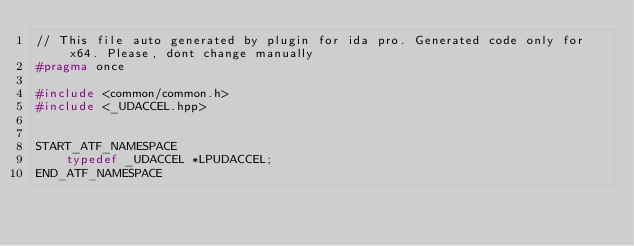<code> <loc_0><loc_0><loc_500><loc_500><_C++_>// This file auto generated by plugin for ida pro. Generated code only for x64. Please, dont change manually
#pragma once

#include <common/common.h>
#include <_UDACCEL.hpp>


START_ATF_NAMESPACE
    typedef _UDACCEL *LPUDACCEL;
END_ATF_NAMESPACE
</code> 